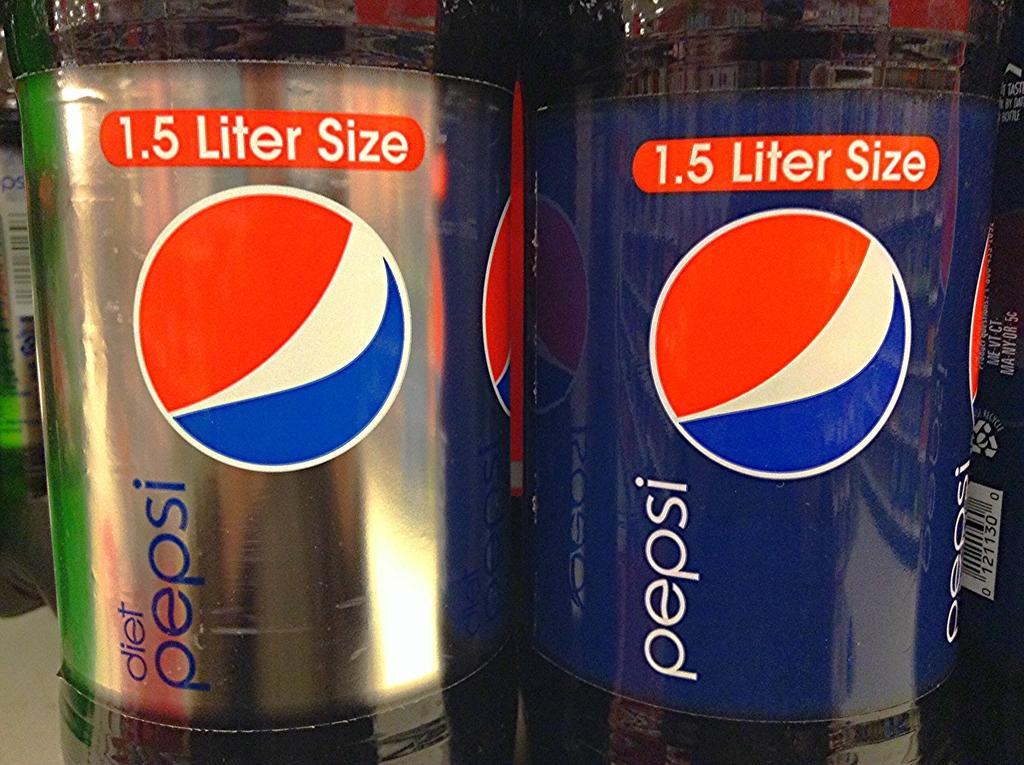<image>
Provide a brief description of the given image. A bottle of diet Pepsi next to a bottle of regular Pepsi. 